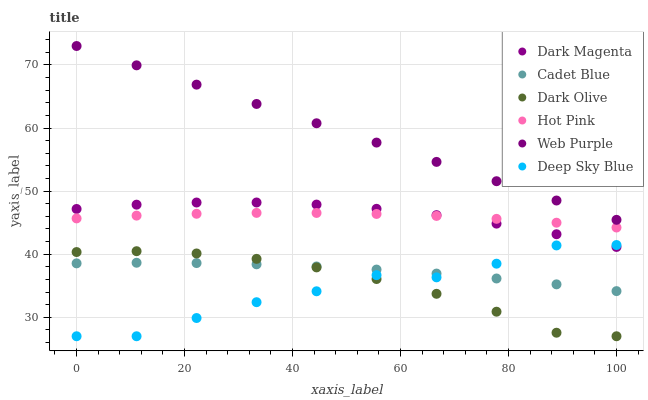Does Deep Sky Blue have the minimum area under the curve?
Answer yes or no. Yes. Does Web Purple have the maximum area under the curve?
Answer yes or no. Yes. Does Dark Magenta have the minimum area under the curve?
Answer yes or no. No. Does Dark Magenta have the maximum area under the curve?
Answer yes or no. No. Is Web Purple the smoothest?
Answer yes or no. Yes. Is Deep Sky Blue the roughest?
Answer yes or no. Yes. Is Dark Magenta the smoothest?
Answer yes or no. No. Is Dark Magenta the roughest?
Answer yes or no. No. Does Dark Olive have the lowest value?
Answer yes or no. Yes. Does Dark Magenta have the lowest value?
Answer yes or no. No. Does Web Purple have the highest value?
Answer yes or no. Yes. Does Dark Magenta have the highest value?
Answer yes or no. No. Is Hot Pink less than Web Purple?
Answer yes or no. Yes. Is Web Purple greater than Cadet Blue?
Answer yes or no. Yes. Does Deep Sky Blue intersect Dark Magenta?
Answer yes or no. Yes. Is Deep Sky Blue less than Dark Magenta?
Answer yes or no. No. Is Deep Sky Blue greater than Dark Magenta?
Answer yes or no. No. Does Hot Pink intersect Web Purple?
Answer yes or no. No. 